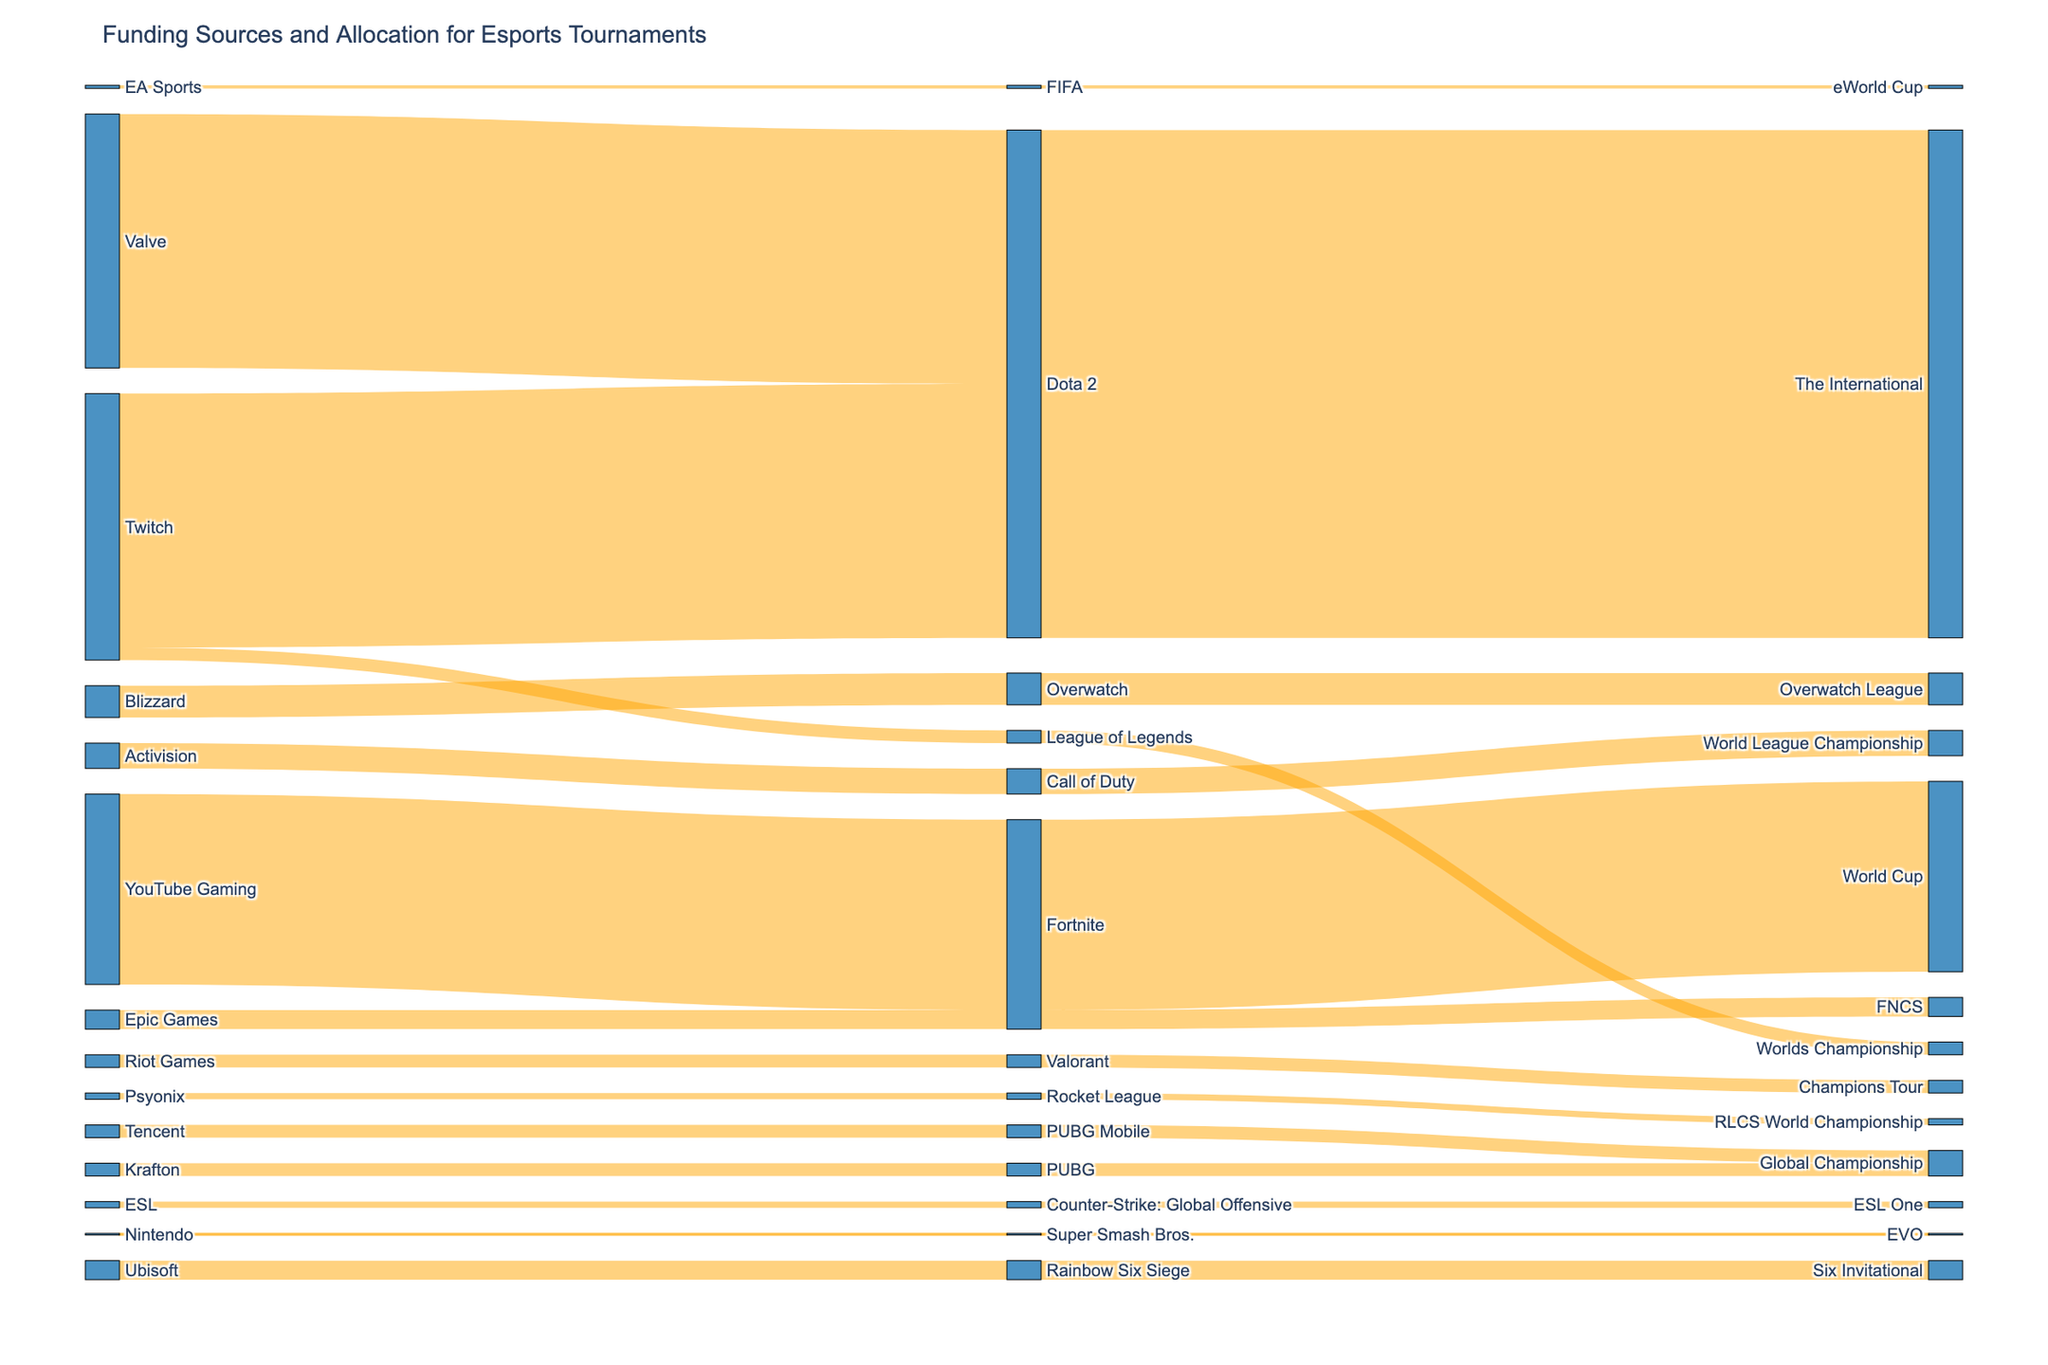What is the title of the figure? The title is usually located at the top of the figure, and it provides a succinct description of what the figure represents.
Answer: Funding Sources and Allocation for Esports Tournaments Which game has the largest prize pool and what is it? To find this, look for the game node associated with the highest value link in the Sankey diagram.
Answer: Dota 2, $40,000,000 Which funding source contributes to the Fortnite World Cup? Identify the link originating from any source node going to the "Fortnite" game node and then proceeding to the "World Cup" tournament node.
Answer: YouTube Gaming What is the combined prize pool for all PUBG tournaments? First, find all the links related to PUBG game (both "PUBG" and "PUBG Mobile") and sum their prize pool values.
Answer: $4,000,000 Which company funds the most different game titles? Count the links from each source node to different game nodes and determine which has the highest count.
Answer: Twitch What is the average prize pool for Counter-Strike: Global Offensive, FIFA, and Overwatch? First, find the prize pools for these games: Counter-Strike: Global Offensive ($1,000,000), FIFA ($500,000), and Overwatch ($5,000,000). Sum these values and divide by the number of games.
Answer: $2,166,667 Do Fortnite tournaments have more funds from Epic Games or YouTube Gaming? Compare the links originating from "Epic Games" and "YouTube Gaming" nodes to "Fortnite" related tournament nodes, summing their values for each source.
Answer: YouTube Gaming What is the prize pool difference between the tournaments with the highest and the lowest prize pools? Identify the highest prize pool ($40,000,000 for Dota 2, The International) and the lowest prize pool ($250,000 for Super Smash Bros., EVO) and subtract the lower value from the higher value.
Answer: $39,750,000 How many funding sources are involved in esports tournaments? Count the number of unique nodes representing the funding sources in the Sankey diagram.
Answer: 10 Which tournament has the second highest prize pool and which game is it associated with? Identify the tournament node with the second highest value link, and trace it back to the game node.
Answer: World Cup, Fortnite 